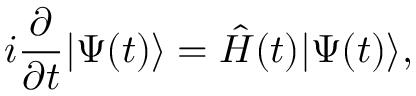Convert formula to latex. <formula><loc_0><loc_0><loc_500><loc_500>i \frac { \partial } { \partial t } | \Psi ( t ) \rangle = \hat { H } ( t ) | \Psi ( t ) \rangle ,</formula> 